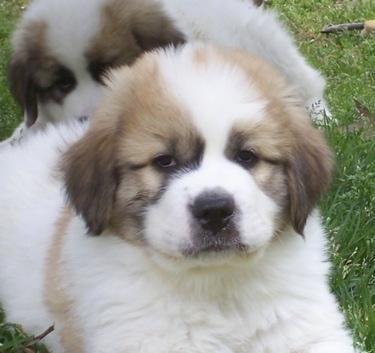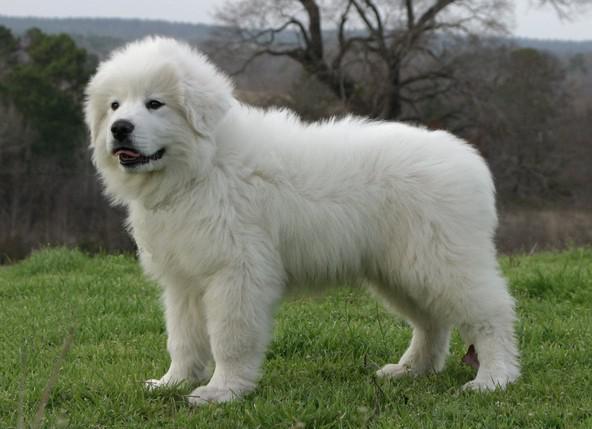The first image is the image on the left, the second image is the image on the right. For the images shown, is this caption "There is two dogs in the left image." true? Answer yes or no. Yes. The first image is the image on the left, the second image is the image on the right. Given the left and right images, does the statement "Each image contains one fluffy young dog in a non-standing position, and all dogs are white with darker fur on their ears and around their eyes." hold true? Answer yes or no. No. 